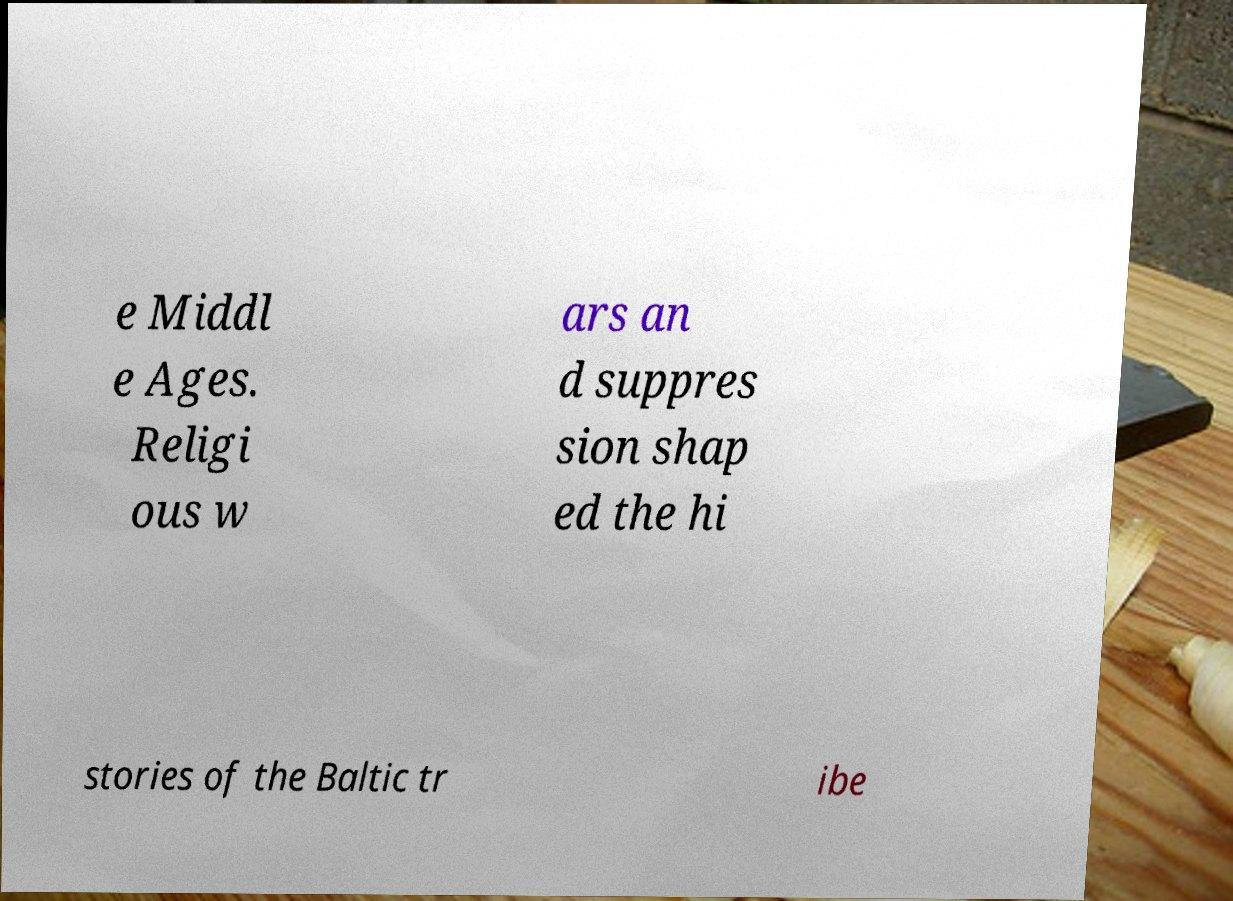Could you extract and type out the text from this image? e Middl e Ages. Religi ous w ars an d suppres sion shap ed the hi stories of the Baltic tr ibe 